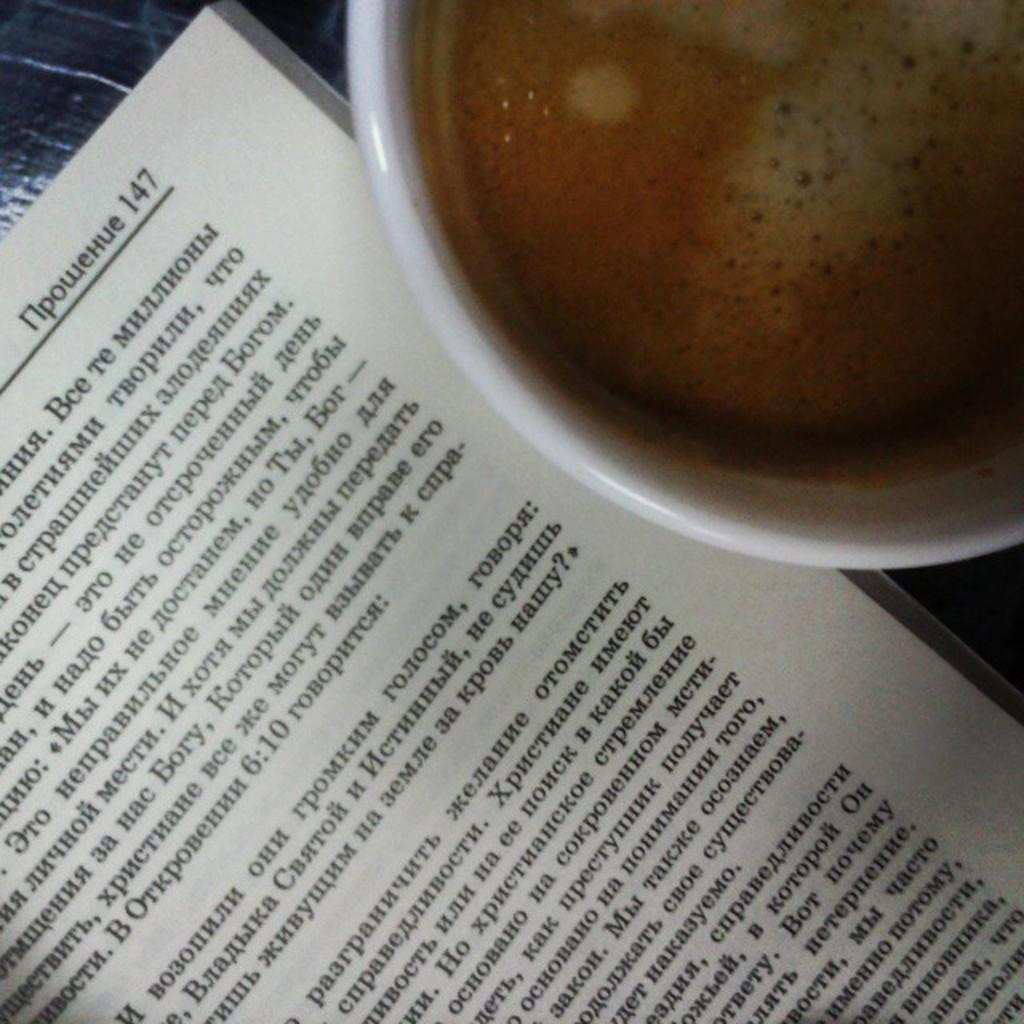<image>
Present a compact description of the photo's key features. A beverage is sitting next to a book opened to page 147. 